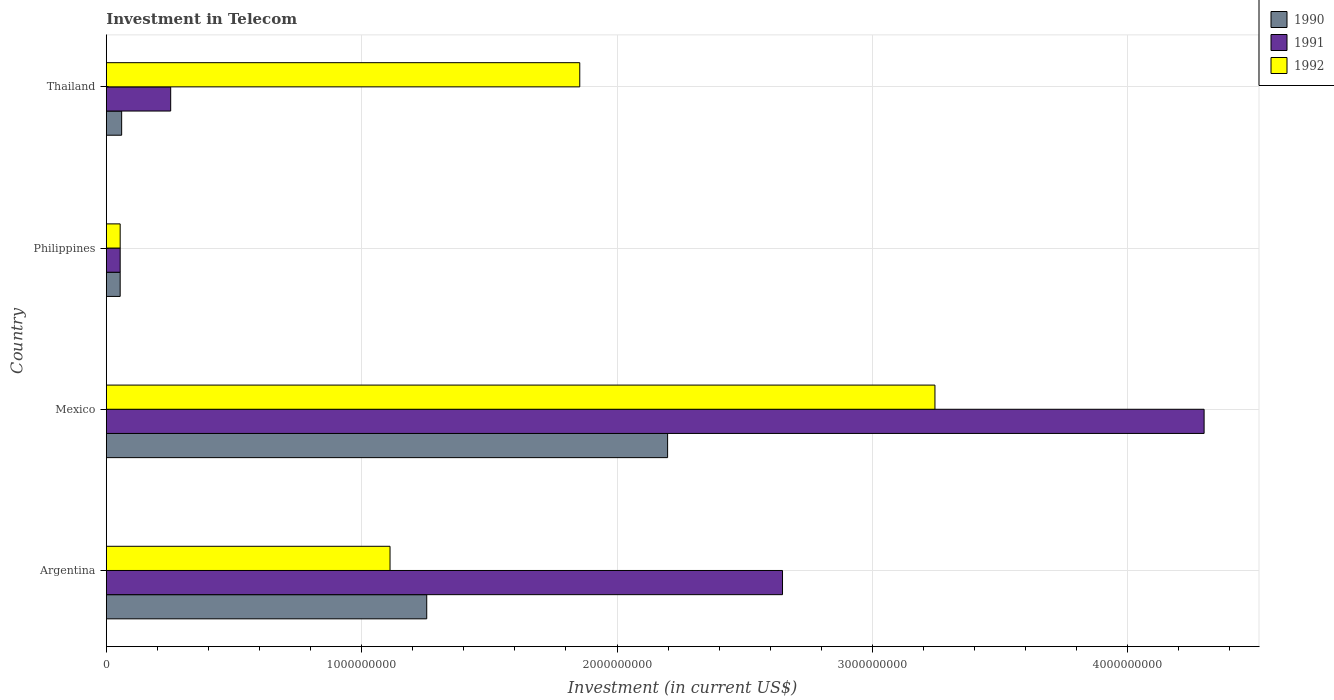How many bars are there on the 3rd tick from the top?
Provide a short and direct response. 3. What is the label of the 4th group of bars from the top?
Offer a terse response. Argentina. What is the amount invested in telecom in 1990 in Argentina?
Offer a very short reply. 1.25e+09. Across all countries, what is the maximum amount invested in telecom in 1992?
Make the answer very short. 3.24e+09. Across all countries, what is the minimum amount invested in telecom in 1991?
Offer a terse response. 5.42e+07. What is the total amount invested in telecom in 1990 in the graph?
Your response must be concise. 3.57e+09. What is the difference between the amount invested in telecom in 1990 in Mexico and that in Thailand?
Make the answer very short. 2.14e+09. What is the difference between the amount invested in telecom in 1990 in Argentina and the amount invested in telecom in 1992 in Philippines?
Make the answer very short. 1.20e+09. What is the average amount invested in telecom in 1990 per country?
Make the answer very short. 8.92e+08. What is the difference between the amount invested in telecom in 1991 and amount invested in telecom in 1992 in Argentina?
Your answer should be very brief. 1.54e+09. What is the ratio of the amount invested in telecom in 1991 in Mexico to that in Philippines?
Your answer should be compact. 79.32. Is the amount invested in telecom in 1990 in Mexico less than that in Philippines?
Your answer should be very brief. No. Is the difference between the amount invested in telecom in 1991 in Mexico and Thailand greater than the difference between the amount invested in telecom in 1992 in Mexico and Thailand?
Keep it short and to the point. Yes. What is the difference between the highest and the second highest amount invested in telecom in 1990?
Keep it short and to the point. 9.43e+08. What is the difference between the highest and the lowest amount invested in telecom in 1991?
Your answer should be compact. 4.24e+09. What does the 3rd bar from the top in Philippines represents?
Your answer should be very brief. 1990. How many bars are there?
Your response must be concise. 12. Are all the bars in the graph horizontal?
Offer a very short reply. Yes. What is the difference between two consecutive major ticks on the X-axis?
Offer a terse response. 1.00e+09. Are the values on the major ticks of X-axis written in scientific E-notation?
Ensure brevity in your answer.  No. Does the graph contain any zero values?
Your response must be concise. No. Does the graph contain grids?
Give a very brief answer. Yes. Where does the legend appear in the graph?
Your response must be concise. Top right. How are the legend labels stacked?
Make the answer very short. Vertical. What is the title of the graph?
Provide a succinct answer. Investment in Telecom. What is the label or title of the X-axis?
Provide a succinct answer. Investment (in current US$). What is the Investment (in current US$) of 1990 in Argentina?
Give a very brief answer. 1.25e+09. What is the Investment (in current US$) in 1991 in Argentina?
Provide a succinct answer. 2.65e+09. What is the Investment (in current US$) of 1992 in Argentina?
Offer a very short reply. 1.11e+09. What is the Investment (in current US$) of 1990 in Mexico?
Offer a terse response. 2.20e+09. What is the Investment (in current US$) of 1991 in Mexico?
Provide a succinct answer. 4.30e+09. What is the Investment (in current US$) in 1992 in Mexico?
Your answer should be very brief. 3.24e+09. What is the Investment (in current US$) in 1990 in Philippines?
Offer a very short reply. 5.42e+07. What is the Investment (in current US$) in 1991 in Philippines?
Give a very brief answer. 5.42e+07. What is the Investment (in current US$) in 1992 in Philippines?
Make the answer very short. 5.42e+07. What is the Investment (in current US$) of 1990 in Thailand?
Give a very brief answer. 6.00e+07. What is the Investment (in current US$) in 1991 in Thailand?
Offer a very short reply. 2.52e+08. What is the Investment (in current US$) of 1992 in Thailand?
Ensure brevity in your answer.  1.85e+09. Across all countries, what is the maximum Investment (in current US$) in 1990?
Provide a succinct answer. 2.20e+09. Across all countries, what is the maximum Investment (in current US$) in 1991?
Give a very brief answer. 4.30e+09. Across all countries, what is the maximum Investment (in current US$) of 1992?
Ensure brevity in your answer.  3.24e+09. Across all countries, what is the minimum Investment (in current US$) of 1990?
Offer a very short reply. 5.42e+07. Across all countries, what is the minimum Investment (in current US$) in 1991?
Give a very brief answer. 5.42e+07. Across all countries, what is the minimum Investment (in current US$) in 1992?
Give a very brief answer. 5.42e+07. What is the total Investment (in current US$) of 1990 in the graph?
Your answer should be compact. 3.57e+09. What is the total Investment (in current US$) of 1991 in the graph?
Offer a very short reply. 7.25e+09. What is the total Investment (in current US$) in 1992 in the graph?
Give a very brief answer. 6.26e+09. What is the difference between the Investment (in current US$) of 1990 in Argentina and that in Mexico?
Your response must be concise. -9.43e+08. What is the difference between the Investment (in current US$) in 1991 in Argentina and that in Mexico?
Keep it short and to the point. -1.65e+09. What is the difference between the Investment (in current US$) of 1992 in Argentina and that in Mexico?
Make the answer very short. -2.13e+09. What is the difference between the Investment (in current US$) in 1990 in Argentina and that in Philippines?
Provide a short and direct response. 1.20e+09. What is the difference between the Investment (in current US$) of 1991 in Argentina and that in Philippines?
Provide a succinct answer. 2.59e+09. What is the difference between the Investment (in current US$) of 1992 in Argentina and that in Philippines?
Keep it short and to the point. 1.06e+09. What is the difference between the Investment (in current US$) of 1990 in Argentina and that in Thailand?
Make the answer very short. 1.19e+09. What is the difference between the Investment (in current US$) in 1991 in Argentina and that in Thailand?
Provide a succinct answer. 2.40e+09. What is the difference between the Investment (in current US$) in 1992 in Argentina and that in Thailand?
Provide a succinct answer. -7.43e+08. What is the difference between the Investment (in current US$) in 1990 in Mexico and that in Philippines?
Give a very brief answer. 2.14e+09. What is the difference between the Investment (in current US$) in 1991 in Mexico and that in Philippines?
Your response must be concise. 4.24e+09. What is the difference between the Investment (in current US$) in 1992 in Mexico and that in Philippines?
Ensure brevity in your answer.  3.19e+09. What is the difference between the Investment (in current US$) of 1990 in Mexico and that in Thailand?
Ensure brevity in your answer.  2.14e+09. What is the difference between the Investment (in current US$) in 1991 in Mexico and that in Thailand?
Your answer should be compact. 4.05e+09. What is the difference between the Investment (in current US$) in 1992 in Mexico and that in Thailand?
Your response must be concise. 1.39e+09. What is the difference between the Investment (in current US$) in 1990 in Philippines and that in Thailand?
Make the answer very short. -5.80e+06. What is the difference between the Investment (in current US$) in 1991 in Philippines and that in Thailand?
Offer a very short reply. -1.98e+08. What is the difference between the Investment (in current US$) of 1992 in Philippines and that in Thailand?
Make the answer very short. -1.80e+09. What is the difference between the Investment (in current US$) in 1990 in Argentina and the Investment (in current US$) in 1991 in Mexico?
Provide a succinct answer. -3.04e+09. What is the difference between the Investment (in current US$) of 1990 in Argentina and the Investment (in current US$) of 1992 in Mexico?
Your answer should be very brief. -1.99e+09. What is the difference between the Investment (in current US$) of 1991 in Argentina and the Investment (in current US$) of 1992 in Mexico?
Make the answer very short. -5.97e+08. What is the difference between the Investment (in current US$) in 1990 in Argentina and the Investment (in current US$) in 1991 in Philippines?
Offer a terse response. 1.20e+09. What is the difference between the Investment (in current US$) in 1990 in Argentina and the Investment (in current US$) in 1992 in Philippines?
Your answer should be very brief. 1.20e+09. What is the difference between the Investment (in current US$) of 1991 in Argentina and the Investment (in current US$) of 1992 in Philippines?
Ensure brevity in your answer.  2.59e+09. What is the difference between the Investment (in current US$) in 1990 in Argentina and the Investment (in current US$) in 1991 in Thailand?
Ensure brevity in your answer.  1.00e+09. What is the difference between the Investment (in current US$) in 1990 in Argentina and the Investment (in current US$) in 1992 in Thailand?
Offer a terse response. -5.99e+08. What is the difference between the Investment (in current US$) of 1991 in Argentina and the Investment (in current US$) of 1992 in Thailand?
Provide a succinct answer. 7.94e+08. What is the difference between the Investment (in current US$) of 1990 in Mexico and the Investment (in current US$) of 1991 in Philippines?
Your answer should be very brief. 2.14e+09. What is the difference between the Investment (in current US$) of 1990 in Mexico and the Investment (in current US$) of 1992 in Philippines?
Provide a short and direct response. 2.14e+09. What is the difference between the Investment (in current US$) of 1991 in Mexico and the Investment (in current US$) of 1992 in Philippines?
Provide a succinct answer. 4.24e+09. What is the difference between the Investment (in current US$) in 1990 in Mexico and the Investment (in current US$) in 1991 in Thailand?
Make the answer very short. 1.95e+09. What is the difference between the Investment (in current US$) of 1990 in Mexico and the Investment (in current US$) of 1992 in Thailand?
Offer a terse response. 3.44e+08. What is the difference between the Investment (in current US$) of 1991 in Mexico and the Investment (in current US$) of 1992 in Thailand?
Your response must be concise. 2.44e+09. What is the difference between the Investment (in current US$) of 1990 in Philippines and the Investment (in current US$) of 1991 in Thailand?
Your answer should be compact. -1.98e+08. What is the difference between the Investment (in current US$) in 1990 in Philippines and the Investment (in current US$) in 1992 in Thailand?
Offer a very short reply. -1.80e+09. What is the difference between the Investment (in current US$) in 1991 in Philippines and the Investment (in current US$) in 1992 in Thailand?
Provide a succinct answer. -1.80e+09. What is the average Investment (in current US$) of 1990 per country?
Offer a terse response. 8.92e+08. What is the average Investment (in current US$) in 1991 per country?
Your answer should be compact. 1.81e+09. What is the average Investment (in current US$) of 1992 per country?
Provide a short and direct response. 1.57e+09. What is the difference between the Investment (in current US$) of 1990 and Investment (in current US$) of 1991 in Argentina?
Provide a short and direct response. -1.39e+09. What is the difference between the Investment (in current US$) of 1990 and Investment (in current US$) of 1992 in Argentina?
Make the answer very short. 1.44e+08. What is the difference between the Investment (in current US$) in 1991 and Investment (in current US$) in 1992 in Argentina?
Make the answer very short. 1.54e+09. What is the difference between the Investment (in current US$) of 1990 and Investment (in current US$) of 1991 in Mexico?
Make the answer very short. -2.10e+09. What is the difference between the Investment (in current US$) of 1990 and Investment (in current US$) of 1992 in Mexico?
Give a very brief answer. -1.05e+09. What is the difference between the Investment (in current US$) of 1991 and Investment (in current US$) of 1992 in Mexico?
Provide a short and direct response. 1.05e+09. What is the difference between the Investment (in current US$) of 1990 and Investment (in current US$) of 1991 in Philippines?
Your response must be concise. 0. What is the difference between the Investment (in current US$) of 1991 and Investment (in current US$) of 1992 in Philippines?
Ensure brevity in your answer.  0. What is the difference between the Investment (in current US$) in 1990 and Investment (in current US$) in 1991 in Thailand?
Make the answer very short. -1.92e+08. What is the difference between the Investment (in current US$) of 1990 and Investment (in current US$) of 1992 in Thailand?
Make the answer very short. -1.79e+09. What is the difference between the Investment (in current US$) in 1991 and Investment (in current US$) in 1992 in Thailand?
Provide a succinct answer. -1.60e+09. What is the ratio of the Investment (in current US$) in 1990 in Argentina to that in Mexico?
Your answer should be very brief. 0.57. What is the ratio of the Investment (in current US$) of 1991 in Argentina to that in Mexico?
Ensure brevity in your answer.  0.62. What is the ratio of the Investment (in current US$) of 1992 in Argentina to that in Mexico?
Offer a terse response. 0.34. What is the ratio of the Investment (in current US$) of 1990 in Argentina to that in Philippines?
Offer a very short reply. 23.15. What is the ratio of the Investment (in current US$) in 1991 in Argentina to that in Philippines?
Make the answer very short. 48.86. What is the ratio of the Investment (in current US$) of 1992 in Argentina to that in Philippines?
Give a very brief answer. 20.5. What is the ratio of the Investment (in current US$) in 1990 in Argentina to that in Thailand?
Ensure brevity in your answer.  20.91. What is the ratio of the Investment (in current US$) in 1991 in Argentina to that in Thailand?
Keep it short and to the point. 10.51. What is the ratio of the Investment (in current US$) of 1992 in Argentina to that in Thailand?
Provide a succinct answer. 0.6. What is the ratio of the Investment (in current US$) in 1990 in Mexico to that in Philippines?
Keep it short and to the point. 40.55. What is the ratio of the Investment (in current US$) of 1991 in Mexico to that in Philippines?
Your response must be concise. 79.32. What is the ratio of the Investment (in current US$) of 1992 in Mexico to that in Philippines?
Keep it short and to the point. 59.87. What is the ratio of the Investment (in current US$) of 1990 in Mexico to that in Thailand?
Your response must be concise. 36.63. What is the ratio of the Investment (in current US$) in 1991 in Mexico to that in Thailand?
Your response must be concise. 17.06. What is the ratio of the Investment (in current US$) in 1992 in Mexico to that in Thailand?
Your answer should be very brief. 1.75. What is the ratio of the Investment (in current US$) in 1990 in Philippines to that in Thailand?
Give a very brief answer. 0.9. What is the ratio of the Investment (in current US$) of 1991 in Philippines to that in Thailand?
Offer a very short reply. 0.22. What is the ratio of the Investment (in current US$) in 1992 in Philippines to that in Thailand?
Your answer should be very brief. 0.03. What is the difference between the highest and the second highest Investment (in current US$) in 1990?
Offer a terse response. 9.43e+08. What is the difference between the highest and the second highest Investment (in current US$) in 1991?
Offer a terse response. 1.65e+09. What is the difference between the highest and the second highest Investment (in current US$) of 1992?
Provide a succinct answer. 1.39e+09. What is the difference between the highest and the lowest Investment (in current US$) of 1990?
Offer a very short reply. 2.14e+09. What is the difference between the highest and the lowest Investment (in current US$) of 1991?
Provide a short and direct response. 4.24e+09. What is the difference between the highest and the lowest Investment (in current US$) of 1992?
Offer a very short reply. 3.19e+09. 